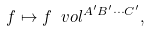Convert formula to latex. <formula><loc_0><loc_0><loc_500><loc_500>f \mapsto f \ v o l ^ { A ^ { \prime } B ^ { \prime } \cdots C ^ { \prime } } ,</formula> 